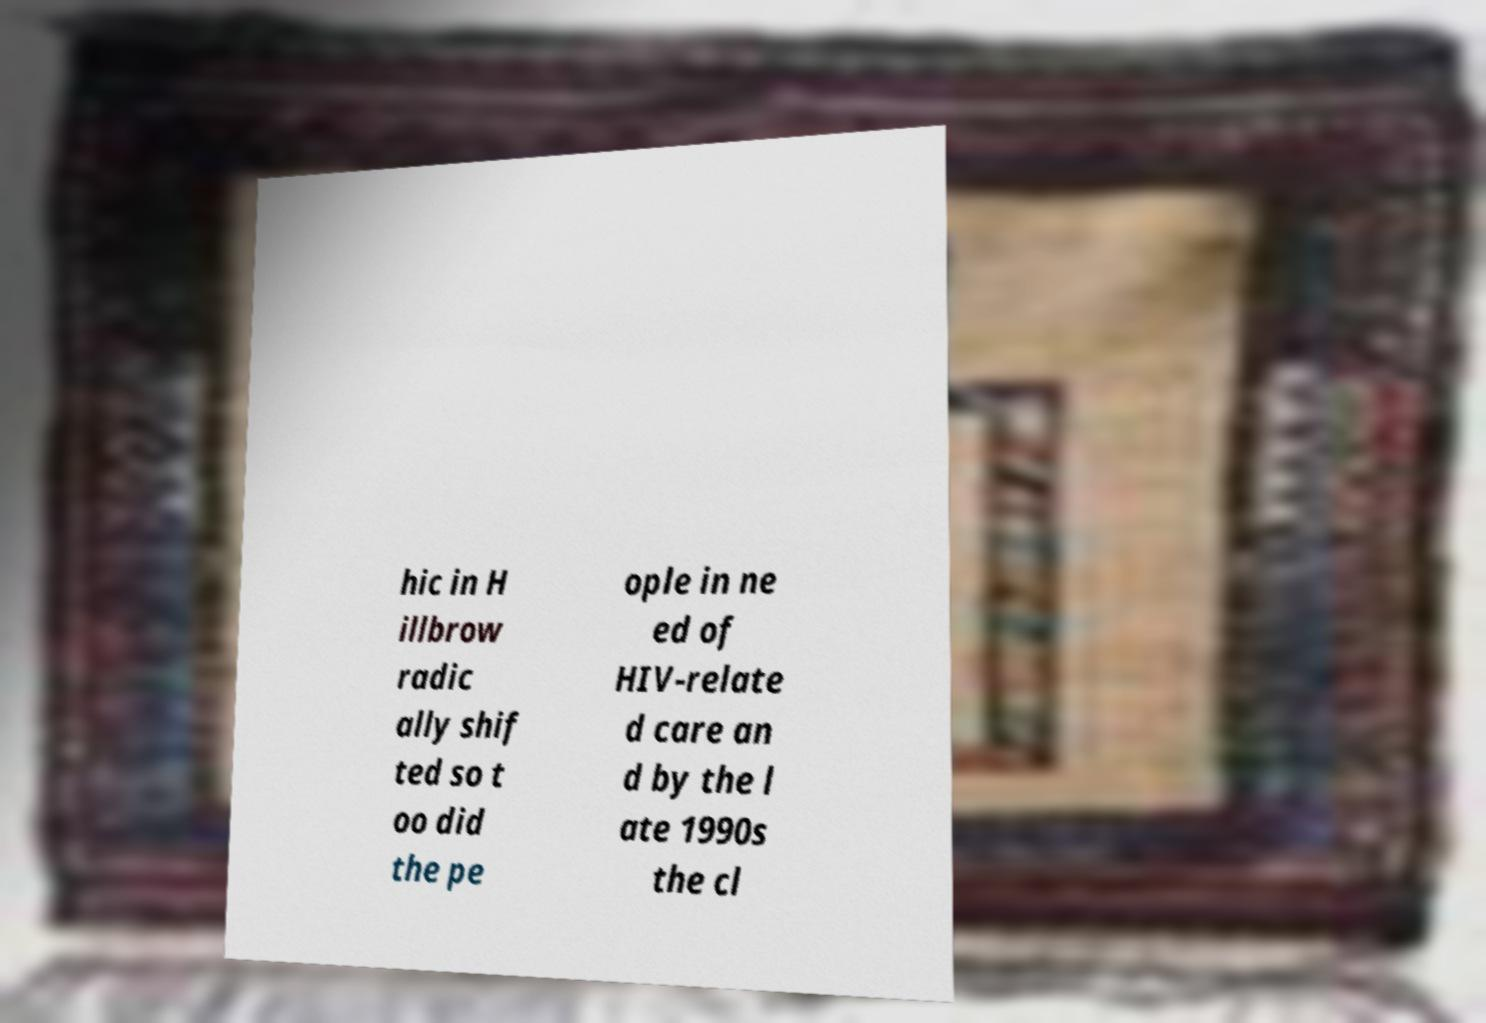Please identify and transcribe the text found in this image. hic in H illbrow radic ally shif ted so t oo did the pe ople in ne ed of HIV-relate d care an d by the l ate 1990s the cl 